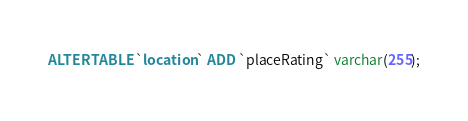Convert code to text. <code><loc_0><loc_0><loc_500><loc_500><_SQL_>ALTER TABLE `location` ADD `placeRating` varchar(255);</code> 